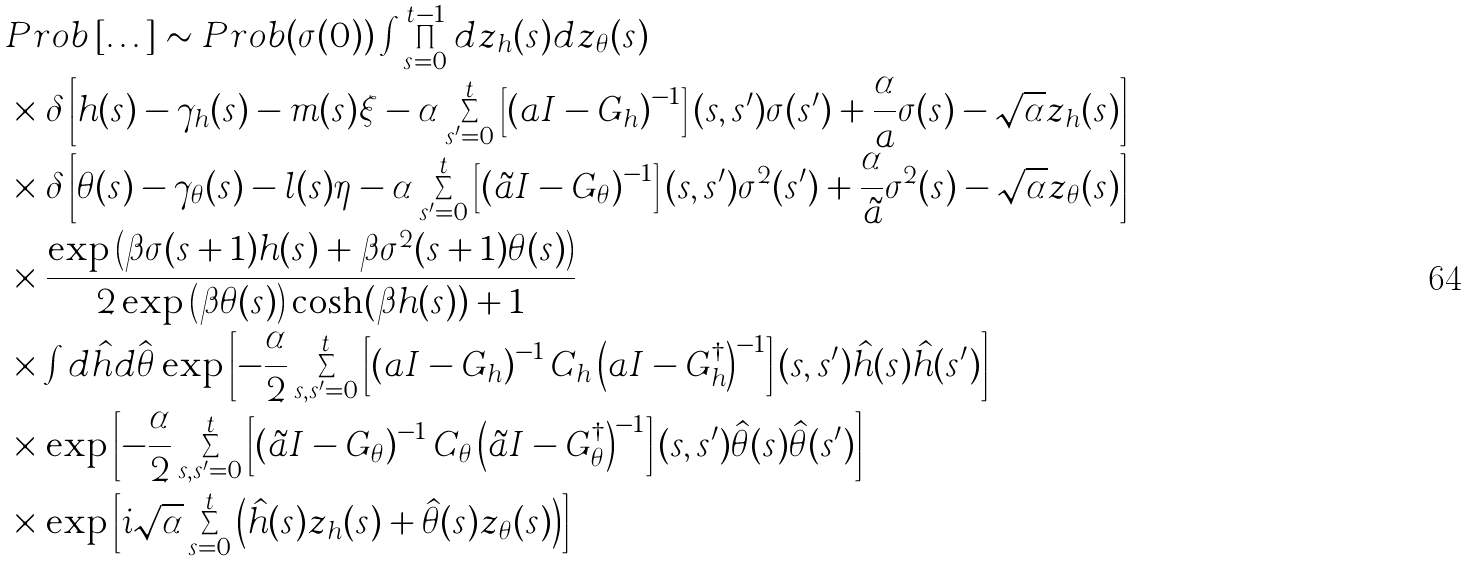Convert formula to latex. <formula><loc_0><loc_0><loc_500><loc_500>& P r o b \left [ \dots \right ] \sim P r o b ( \sigma ( 0 ) ) \int \prod _ { s = 0 } ^ { t - 1 } d z _ { h } ( s ) d z _ { \theta } ( s ) \\ & \times \delta \left [ h ( s ) - \gamma _ { h } ( s ) - m ( s ) \xi - \alpha \sum _ { s ^ { \prime } = 0 } ^ { t } \left [ \left ( a { I } - { G } _ { h } \right ) ^ { - 1 } \right ] ( s , s ^ { \prime } ) \sigma ( s ^ { \prime } ) + \frac { \alpha } { a } \sigma ( s ) - \sqrt { \alpha } z _ { h } ( s ) \right ] \\ & \times \delta \left [ \theta ( s ) - \gamma _ { \theta } ( s ) - l ( s ) \eta - \alpha \sum _ { s ^ { \prime } = 0 } ^ { t } \left [ \left ( \tilde { a } { I } - { G } _ { \theta } \right ) ^ { - 1 } \right ] ( s , s ^ { \prime } ) \sigma ^ { 2 } ( s ^ { \prime } ) + \frac { \alpha } { \tilde { a } } \sigma ^ { 2 } ( s ) - \sqrt { \alpha } z _ { \theta } ( s ) \right ] \\ & \times \frac { \exp { \left ( \beta \sigma ( s + 1 ) h ( s ) + \beta \sigma ^ { 2 } ( s + 1 ) \theta ( s ) \right ) } } { 2 \exp { \left ( \beta \theta ( s ) \right ) } \cosh ( \beta h ( s ) ) + 1 } \\ & \times \int d { \hat { h } } d { \hat { \boldsymbol \theta } } \exp { \left [ - \frac { \alpha } { 2 } \sum _ { s , s ^ { \prime } = 0 } ^ { t } \left [ \left ( a { I } - { G } _ { h } \right ) ^ { - 1 } { C } _ { h } \left ( a { I } - { G } _ { h } ^ { \dagger } \right ) ^ { - 1 } \right ] ( s , s ^ { \prime } ) \hat { h } ( s ) \hat { h } ( s ^ { \prime } ) \right ] } \\ & \times \exp { \left [ - \frac { \alpha } { 2 } \sum _ { s , s ^ { \prime } = 0 } ^ { t } \left [ \left ( \tilde { a } { I } - { G } _ { \theta } \right ) ^ { - 1 } { C } _ { \theta } \left ( \tilde { a } { I } - { G } _ { \theta } ^ { \dagger } \right ) ^ { - 1 } \right ] ( s , s ^ { \prime } ) \hat { \theta } ( s ) \hat { \theta } ( s ^ { \prime } ) \right ] } \\ & \times \exp { \left [ i \sqrt { \alpha } \sum _ { s = 0 } ^ { t } \left ( \hat { h } ( s ) z _ { h } ( s ) + \hat { \theta } ( s ) z _ { \theta } ( s ) \right ) \right ] }</formula> 